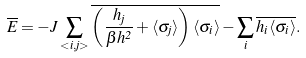Convert formula to latex. <formula><loc_0><loc_0><loc_500><loc_500>\overline { E } = - J \sum _ { < i , j > } \overline { \left ( \frac { h _ { j } } { \beta h ^ { 2 } } + \langle \sigma _ { j } \rangle \right ) \langle \sigma _ { i } \rangle } - \sum _ { i } \overline { h _ { i } \langle \sigma _ { i } \rangle } .</formula> 